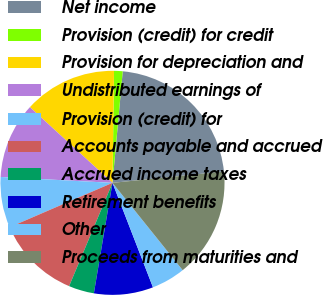<chart> <loc_0><loc_0><loc_500><loc_500><pie_chart><fcel>Net income<fcel>Provision (credit) for credit<fcel>Provision for depreciation and<fcel>Undistributed earnings of<fcel>Provision (credit) for<fcel>Accounts payable and accrued<fcel>Accrued income taxes<fcel>Retirement benefits<fcel>Other<fcel>Proceeds from maturities and<nl><fcel>21.93%<fcel>1.24%<fcel>13.41%<fcel>10.97%<fcel>7.32%<fcel>12.19%<fcel>3.67%<fcel>8.54%<fcel>4.89%<fcel>15.84%<nl></chart> 